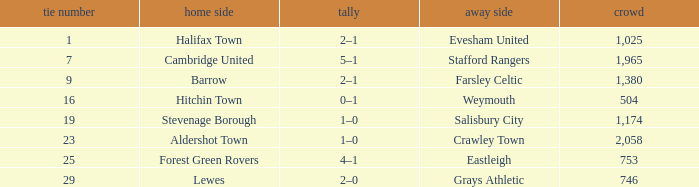Who was the away team in a tie no larger than 16 with forest green rovers at home? Eastleigh. 